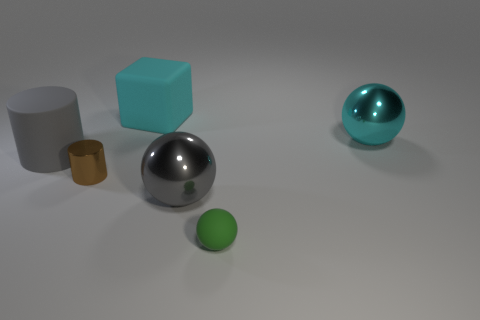Add 2 small cylinders. How many objects exist? 8 Subtract all cylinders. How many objects are left? 4 Add 5 green rubber balls. How many green rubber balls exist? 6 Subtract 0 red cylinders. How many objects are left? 6 Subtract all brown cubes. Subtract all large matte things. How many objects are left? 4 Add 5 large gray rubber cylinders. How many large gray rubber cylinders are left? 6 